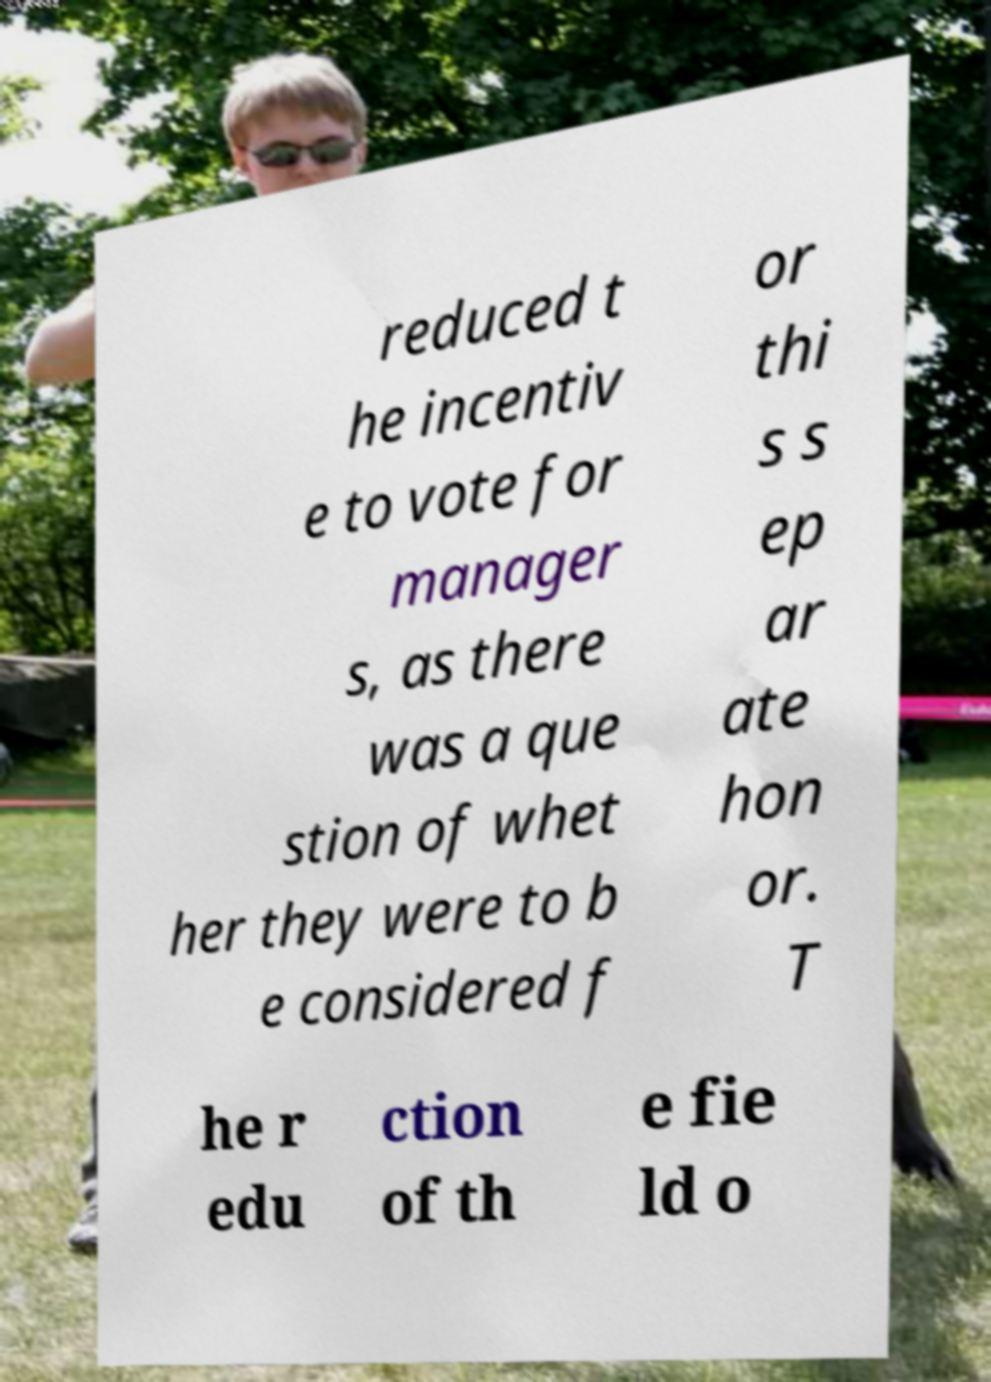There's text embedded in this image that I need extracted. Can you transcribe it verbatim? reduced t he incentiv e to vote for manager s, as there was a que stion of whet her they were to b e considered f or thi s s ep ar ate hon or. T he r edu ction of th e fie ld o 